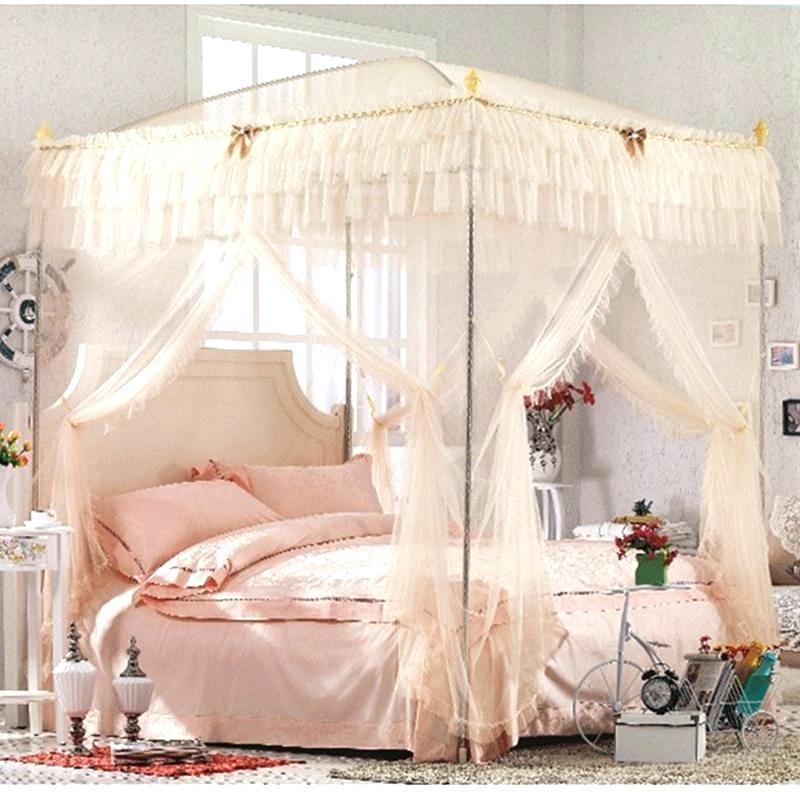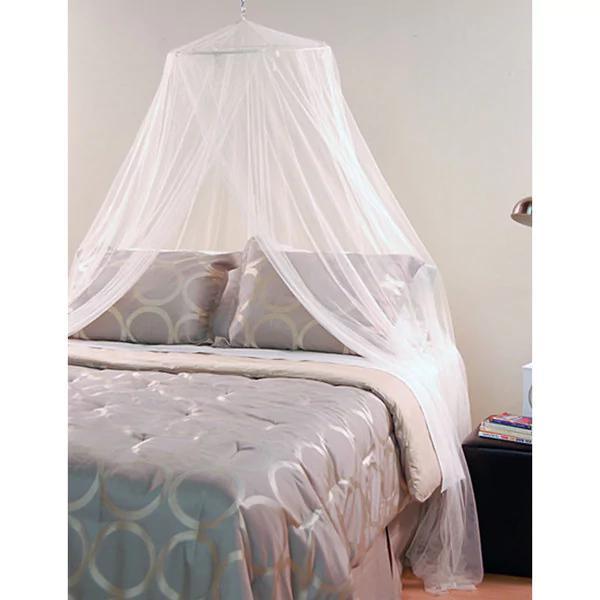The first image is the image on the left, the second image is the image on the right. Assess this claim about the two images: "The left and right image contains the same number of square open lace canopies.". Correct or not? Answer yes or no. No. The first image is the image on the left, the second image is the image on the right. Considering the images on both sides, is "One image shows a sheer pinkish canopy with a ruffled border around the top, on a four-post bed." valid? Answer yes or no. Yes. 